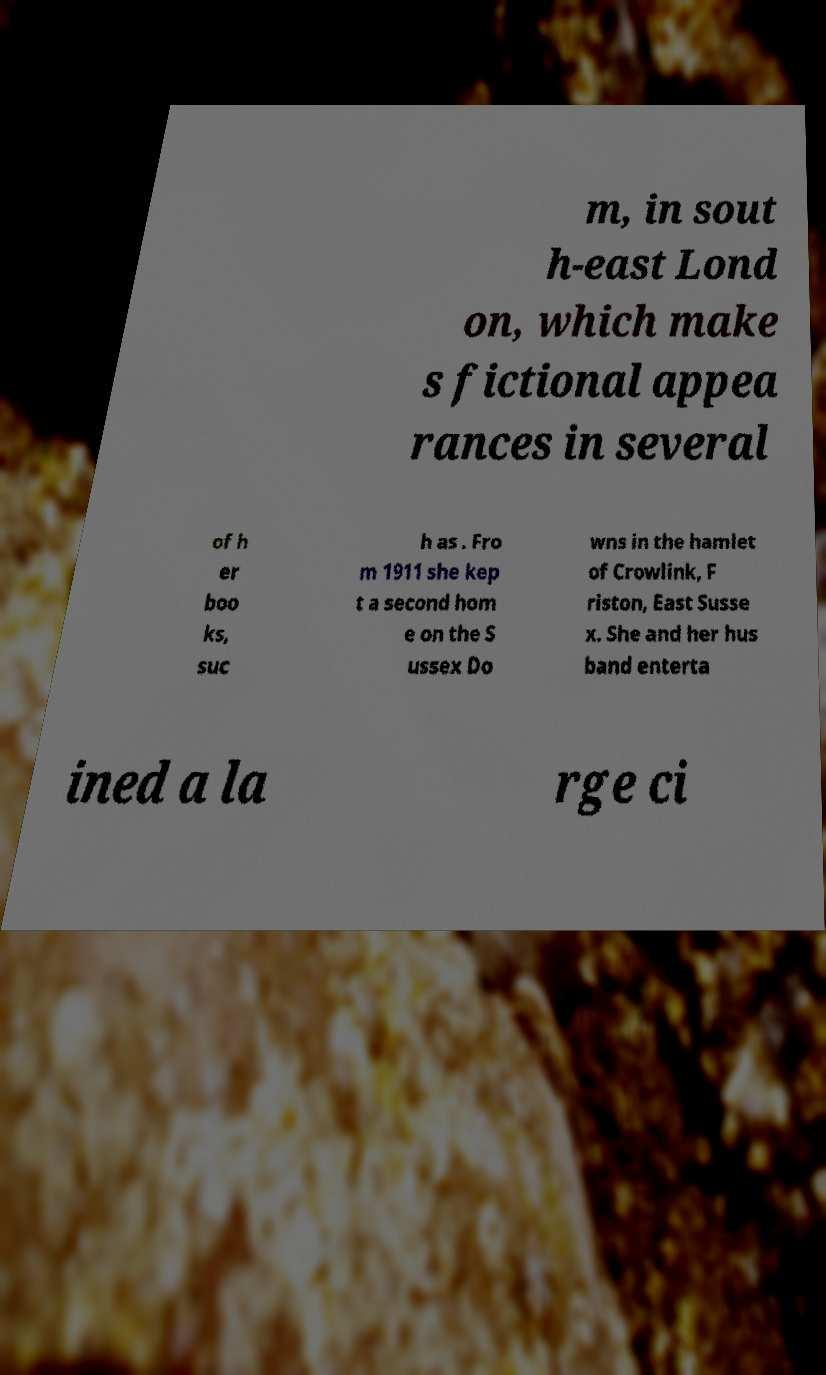Please identify and transcribe the text found in this image. m, in sout h-east Lond on, which make s fictional appea rances in several of h er boo ks, suc h as . Fro m 1911 she kep t a second hom e on the S ussex Do wns in the hamlet of Crowlink, F riston, East Susse x. She and her hus band enterta ined a la rge ci 